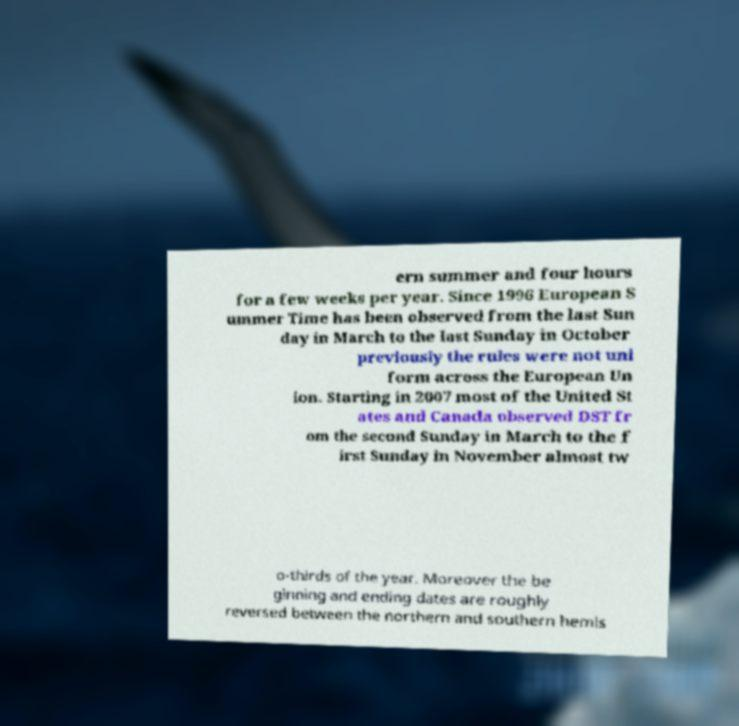What messages or text are displayed in this image? I need them in a readable, typed format. ern summer and four hours for a few weeks per year. Since 1996 European S ummer Time has been observed from the last Sun day in March to the last Sunday in October previously the rules were not uni form across the European Un ion. Starting in 2007 most of the United St ates and Canada observed DST fr om the second Sunday in March to the f irst Sunday in November almost tw o-thirds of the year. Moreover the be ginning and ending dates are roughly reversed between the northern and southern hemis 